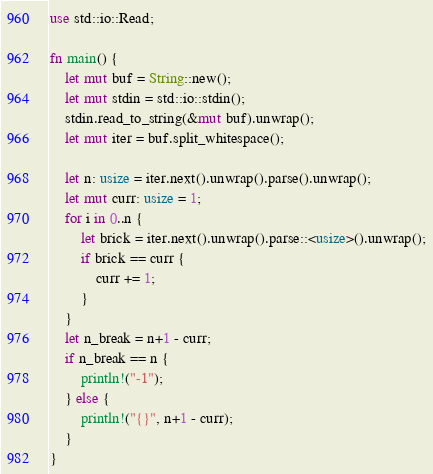Convert code to text. <code><loc_0><loc_0><loc_500><loc_500><_Rust_>use std::io::Read;

fn main() {
    let mut buf = String::new();
    let mut stdin = std::io::stdin();
    stdin.read_to_string(&mut buf).unwrap();
    let mut iter = buf.split_whitespace();

    let n: usize = iter.next().unwrap().parse().unwrap();
    let mut curr: usize = 1;
    for i in 0..n {
        let brick = iter.next().unwrap().parse::<usize>().unwrap();
        if brick == curr {
            curr += 1;
        }
    }
    let n_break = n+1 - curr;
    if n_break == n {
        println!("-1");
    } else {
        println!("{}", n+1 - curr);
    }
}
</code> 